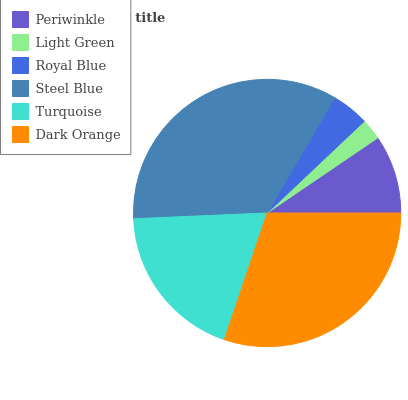Is Light Green the minimum?
Answer yes or no. Yes. Is Steel Blue the maximum?
Answer yes or no. Yes. Is Royal Blue the minimum?
Answer yes or no. No. Is Royal Blue the maximum?
Answer yes or no. No. Is Royal Blue greater than Light Green?
Answer yes or no. Yes. Is Light Green less than Royal Blue?
Answer yes or no. Yes. Is Light Green greater than Royal Blue?
Answer yes or no. No. Is Royal Blue less than Light Green?
Answer yes or no. No. Is Turquoise the high median?
Answer yes or no. Yes. Is Periwinkle the low median?
Answer yes or no. Yes. Is Dark Orange the high median?
Answer yes or no. No. Is Dark Orange the low median?
Answer yes or no. No. 